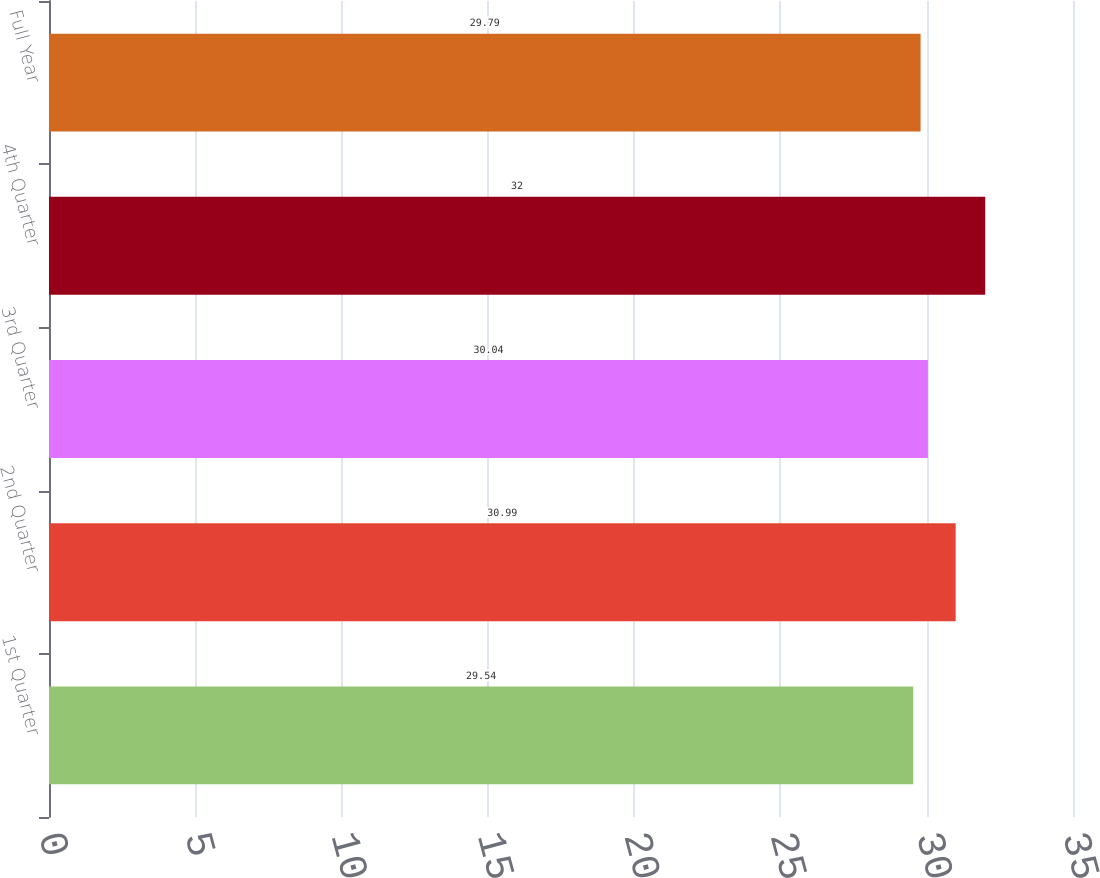<chart> <loc_0><loc_0><loc_500><loc_500><bar_chart><fcel>1st Quarter<fcel>2nd Quarter<fcel>3rd Quarter<fcel>4th Quarter<fcel>Full Year<nl><fcel>29.54<fcel>30.99<fcel>30.04<fcel>32<fcel>29.79<nl></chart> 